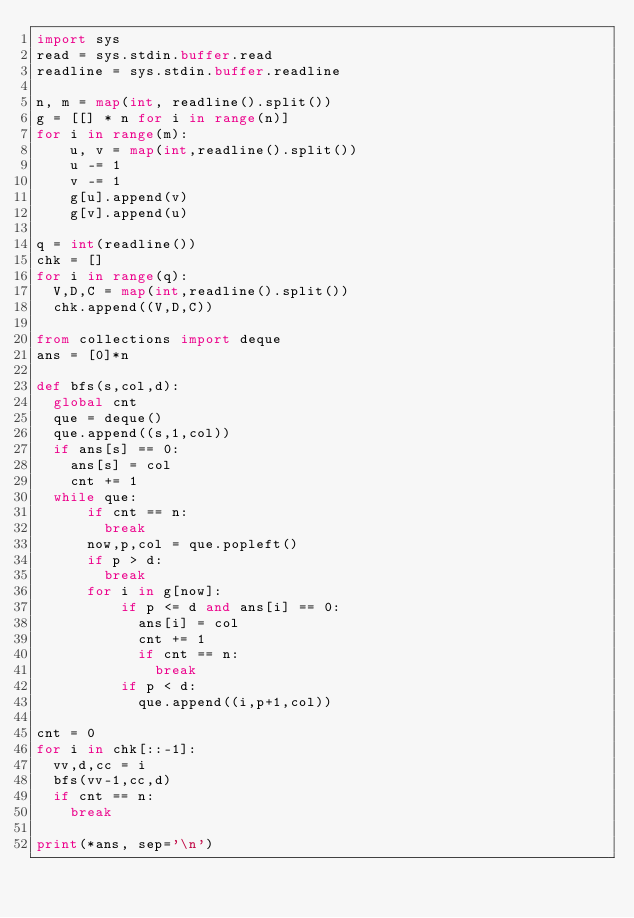<code> <loc_0><loc_0><loc_500><loc_500><_Python_>import sys
read = sys.stdin.buffer.read
readline = sys.stdin.buffer.readline

n, m = map(int, readline().split())
g = [[] * n for i in range(n)]
for i in range(m):
    u, v = map(int,readline().split())
    u -= 1
    v -= 1
    g[u].append(v)
    g[v].append(u)
    
q = int(readline())
chk = []
for i in range(q):
  V,D,C = map(int,readline().split())
  chk.append((V,D,C))
  
from collections import deque
ans = [0]*n

def bfs(s,col,d):
  global cnt
  que = deque()
  que.append((s,1,col))
  if ans[s] == 0:
    ans[s] = col
    cnt += 1
  while que:
      if cnt == n:
        break    
      now,p,col = que.popleft()
      if p > d:
        break
      for i in g[now]:
          if p <= d and ans[i] == 0:
            ans[i] = col
            cnt += 1
            if cnt == n:
              break           
          if p < d:
            que.append((i,p+1,col))

cnt = 0
for i in chk[::-1]:
  vv,d,cc = i
  bfs(vv-1,cc,d)
  if cnt == n:
    break
    
print(*ans, sep='\n')</code> 